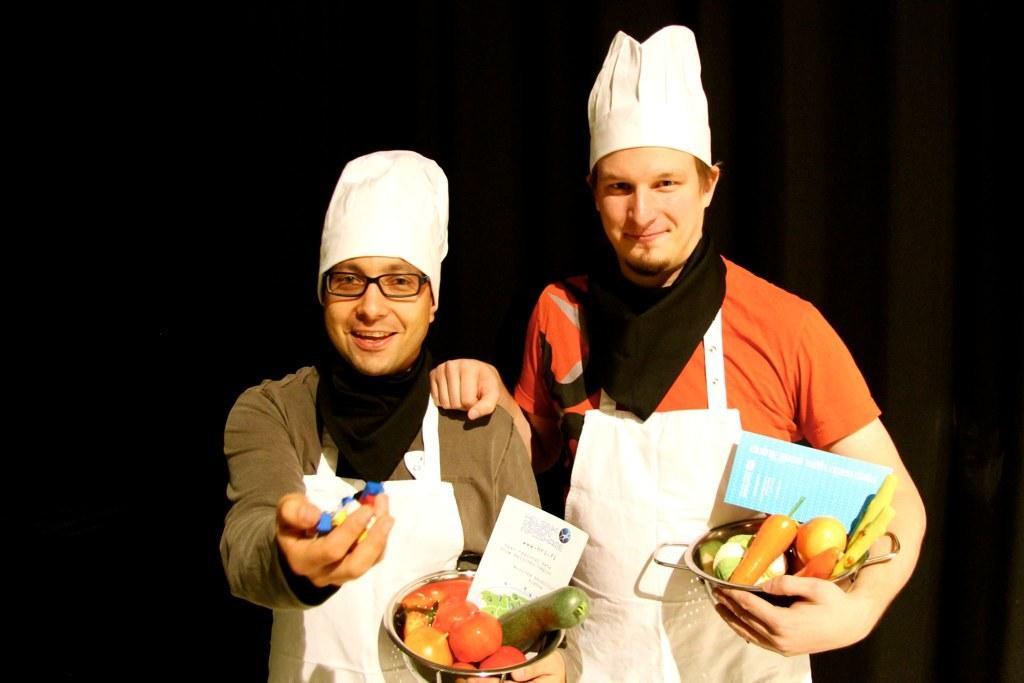Can you describe this image briefly? In this picture, we see two men who are wearing the aprons are standing. They are smiling and they are posing for the photo. They are wearing the chef hats and they are holding a bowl containing fruits, vegetables and a card. The man on the left side is wearing the spectacles and he is holding the objects in his hand. In the background, it is black in color. 